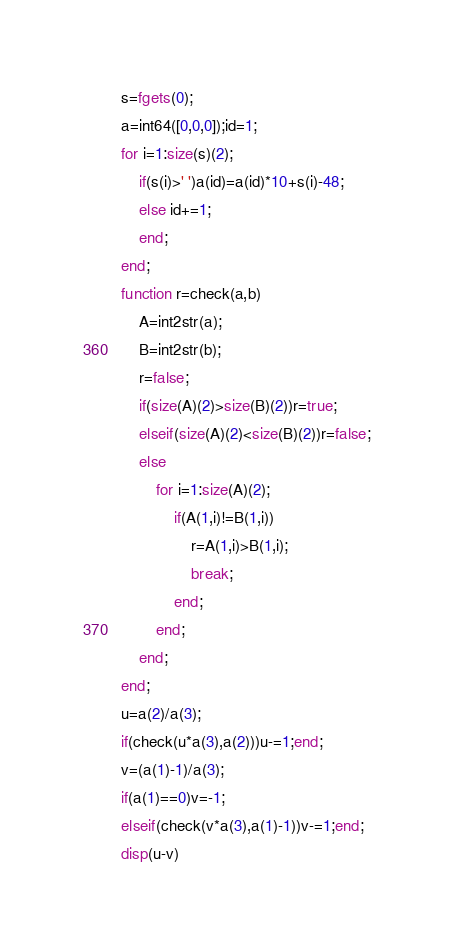<code> <loc_0><loc_0><loc_500><loc_500><_Octave_>s=fgets(0);
a=int64([0,0,0]);id=1;
for i=1:size(s)(2);
	if(s(i)>' ')a(id)=a(id)*10+s(i)-48;
	else id+=1;
	end;
end;
function r=check(a,b)
	A=int2str(a);
	B=int2str(b);
	r=false;
	if(size(A)(2)>size(B)(2))r=true;
	elseif(size(A)(2)<size(B)(2))r=false;
	else
		for i=1:size(A)(2);
			if(A(1,i)!=B(1,i))
				r=A(1,i)>B(1,i);
				break;
			end;
		end;
	end;
end;
u=a(2)/a(3);
if(check(u*a(3),a(2)))u-=1;end;
v=(a(1)-1)/a(3);
if(a(1)==0)v=-1;
elseif(check(v*a(3),a(1)-1))v-=1;end;
disp(u-v)
</code> 